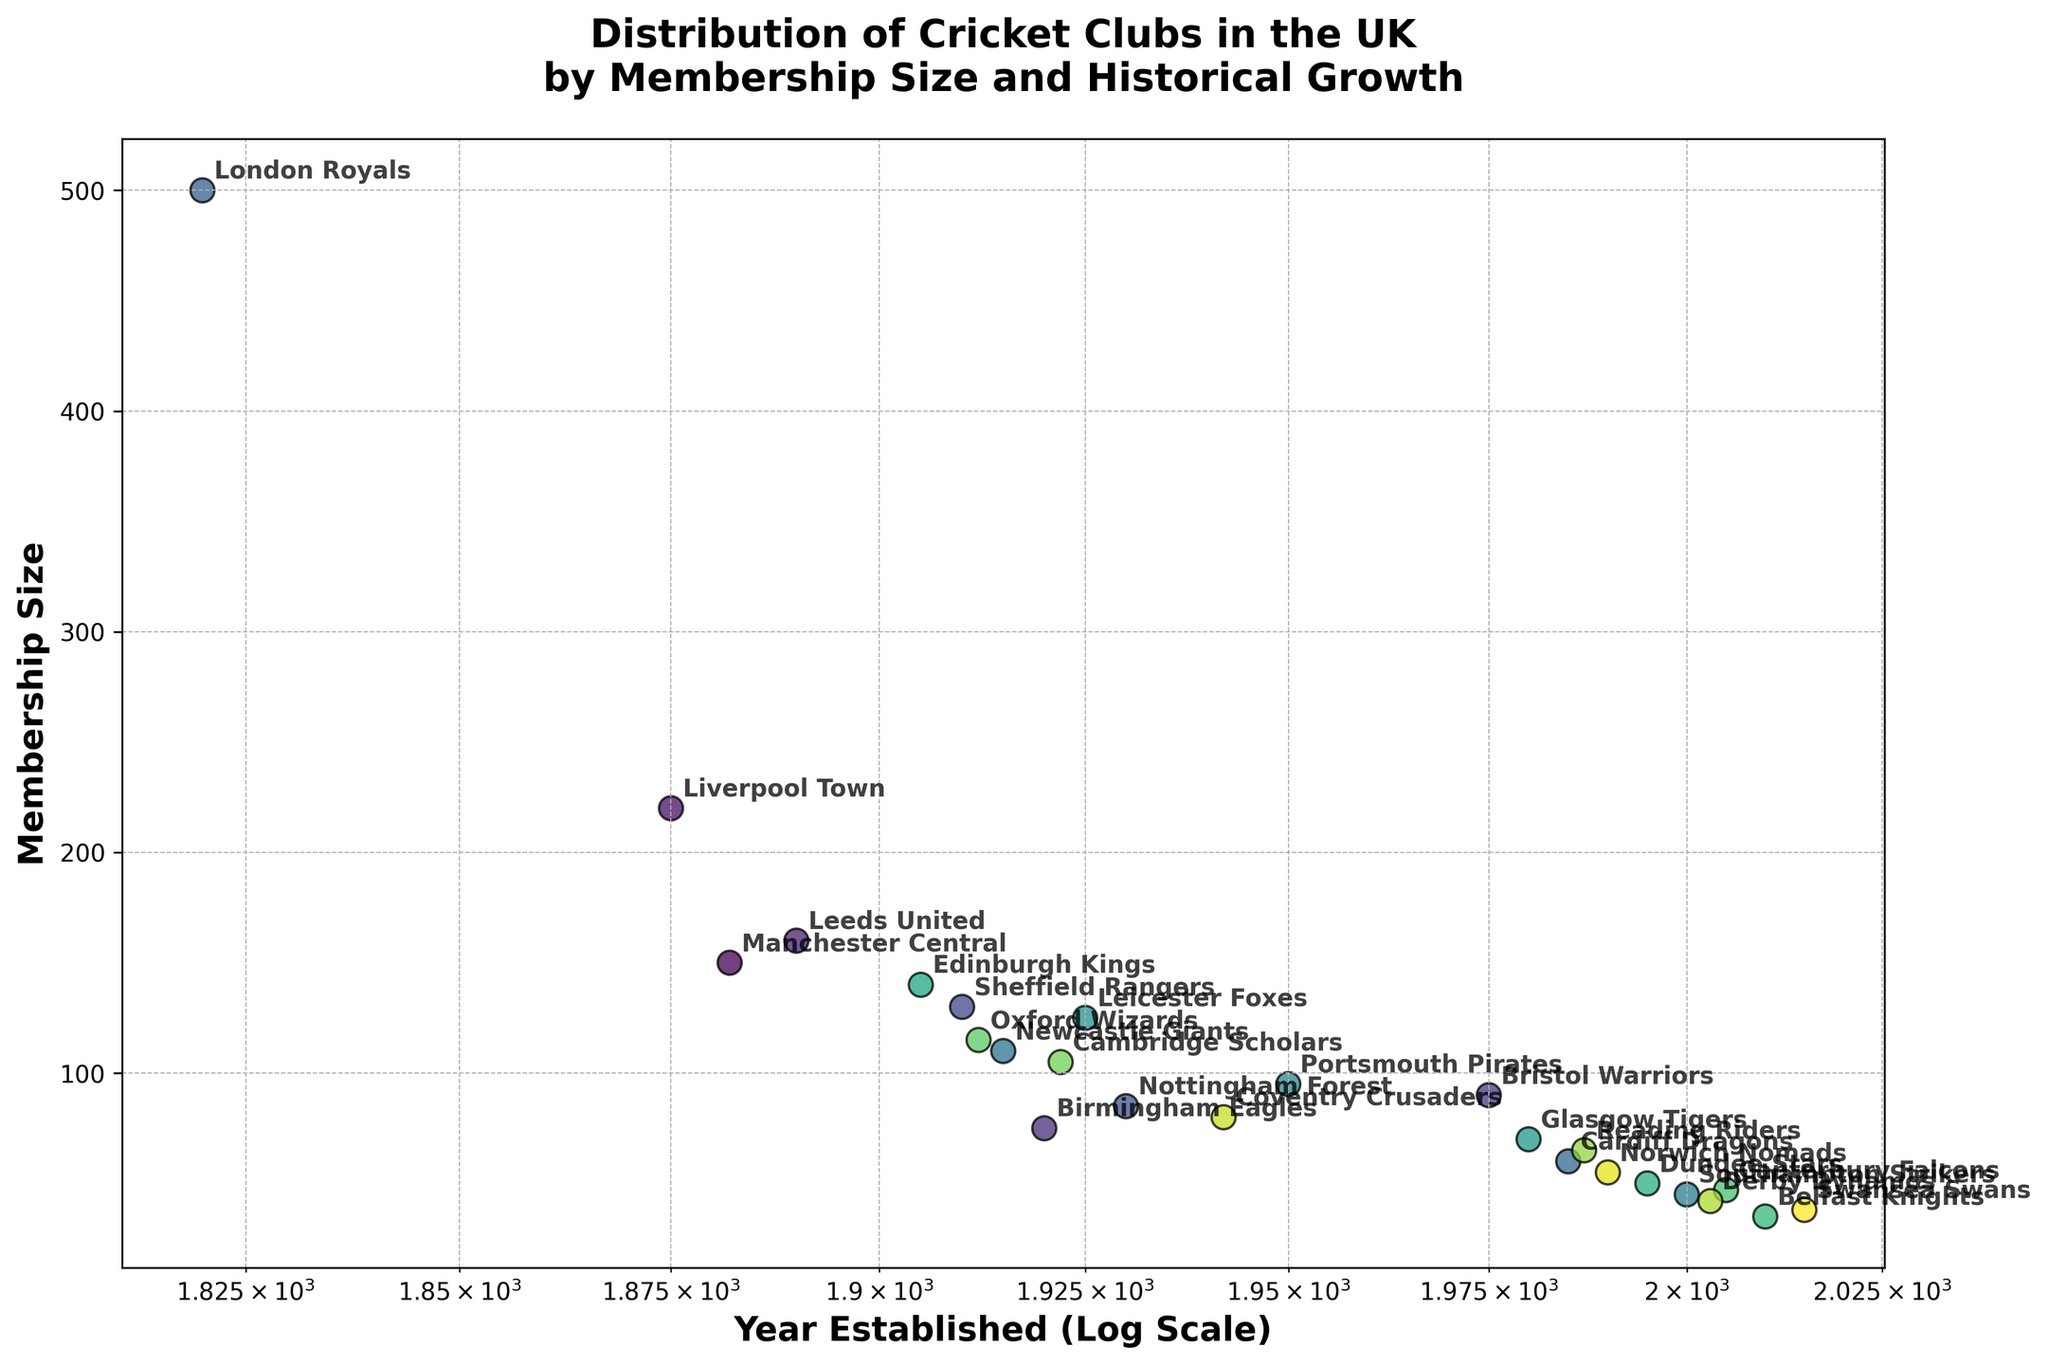What is the largest membership size among the cricket clubs? By examining the scatter plot, the point representing the London Royals stands out as the highest on the y-axis, indicating the largest membership size.
Answer: 500 Which cricket club has the smallest membership size, and in what year was it established? Looking for the point with the lowest y-value on the scatter plot, the Belfast Knights have the smallest membership size. The x-value shows it was established in 2010.
Answer: Belfast Knights, 2010 How many clubs have a membership size greater than 150? Count the points above the y-value of 150. The clubs are Liverpool Town, London Royals, and Leeds United.
Answer: 3 Compare the membership size of the Oxford Wizards and Cambridge Scholars. Which one has a larger membership size? Locate both clubs on the plot. The Oxford Wizards (115 members) is comparatively higher on the y-axis than the Cambridge Scholars (105 members). Therefore, Oxford Wizards has a larger membership size.
Answer: Oxford Wizards What is the average membership size of clubs established after 2000? Identify clubs established after 2000 and average their membership sizes: Southampton Strikers (45), Swansea Swans (38), Derby Dynamos (42), Belfast Knights (35), Canterbury Falcons (47). Calculate (45 + 38 + 42 + 35 + 47) / 5 = 41.4.
Answer: 41.4 Which club established before 1900 has the smallest membership size, and what is that size? Identify points on the left side of the axis (established before 1900) and find the one with the lowest y-value. The Manchester Central, established in 1882, has a membership size of 150.
Answer: Manchester Central, 150 What is the difference in membership sizes between the two clubs established in the 1980s? Locate clubs established in the 1980s: Cardiff Dragons (60) and Reading Riders (65). Calculate the difference: 65 - 60 = 5.
Answer: 5 How does the membership size of Glasgow Tigers compare to Edinburgh Kings? Locate both clubs on the plot and note their y-values. The y-value for Edinburgh Kings (140) is higher than Glasgow Tigers (70), indicating Edinburgh Kings have a larger membership.
Answer: Edinburgh Kings has a larger membership size What is the average year of establishment for clubs with membership sizes over 100? Identify clubs with membership over 100: Manchester Central, Liverpool Town, Leeds United, Sheffield Rangers, London Royals, Newcastle Giants, Leicester Foxes, Edinburgh Kings, Oxford Wizards, Cambridge Scholars, Coventry Crusaders. Calculate the average year of establishment: (1882 + 1875 + 1890 + 1910 + 1820 + 1915 + 1925 + 1905 + 1912 + 1922 + 1942) / 11 = 1901.
Answer: 1901 How many clubs have less than 50 members and were established after 2000? Locate points on the plot with membership sizes less than 50 and filter those established after 2000: Southampton Strikers, Belfast Knights, Derby Dynamos, Swansea Swans.
Answer: 4 